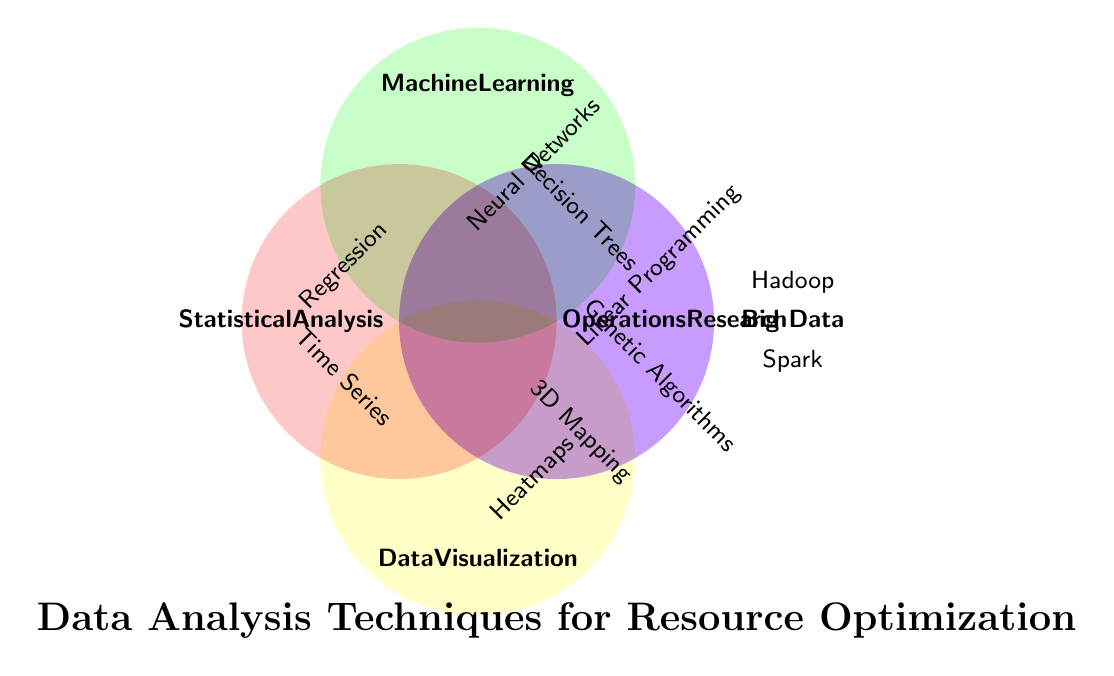What is the main theme of the Venn Diagram? The title at the bottom of the diagram indicates the main theme.
Answer: Data Analysis Techniques for Resource Optimization Which category includes Neural Networks? Neural Networks is placed near the section labeled "Machine Learning" at the top-right.
Answer: Machine Learning How many categories are represented in the diagram? Labels outside the circles represent the categories. Count them: Statistical Analysis, Machine Learning, Operations Research, Data Visualization, and Big Data.
Answer: 5 Identify a technique used in Data Visualization. Techniques are listed inside the circle labeled "Data Visualization." They are Heatmaps and 3D Mapping.
Answer: Heatmaps (or 3D Mapping) What is the color used for the Operations Research category? The circle for Operations Research is on the bottom right and it has a yellow color.
Answer: Yellow List all techniques under Statistical Analysis. The techniques appear inside the circle labeled Statistical Analysis, which are Regression Analysis and Time Series Forecasting.
Answer: Regression Analysis, Time Series Forecasting Which category overlaps with Data Visualization and is also represented with a green color? Identify the green circle, which is Machine Learning, and since it does not overlap with Data Visualization, the answer should be "none."
Answer: None Are Hadoop and Spark part of the same category? Both Hadoop and Spark are inside the circle labeled "Big Data."
Answer: Yes Which category has the most techniques listed? Count techniques within each category: Statistical Analysis (2), Machine Learning (2), Operations Research (2), Data Visualization (2), Big Data (2). All categories have equal numbers of techniques.
Answer: All equally Does the Venn Diagram show the intersection between Statistical Analysis and Data Visualization? There is no overlap between the circles representing Statistical Analysis and Data Visualization.
Answer: No 